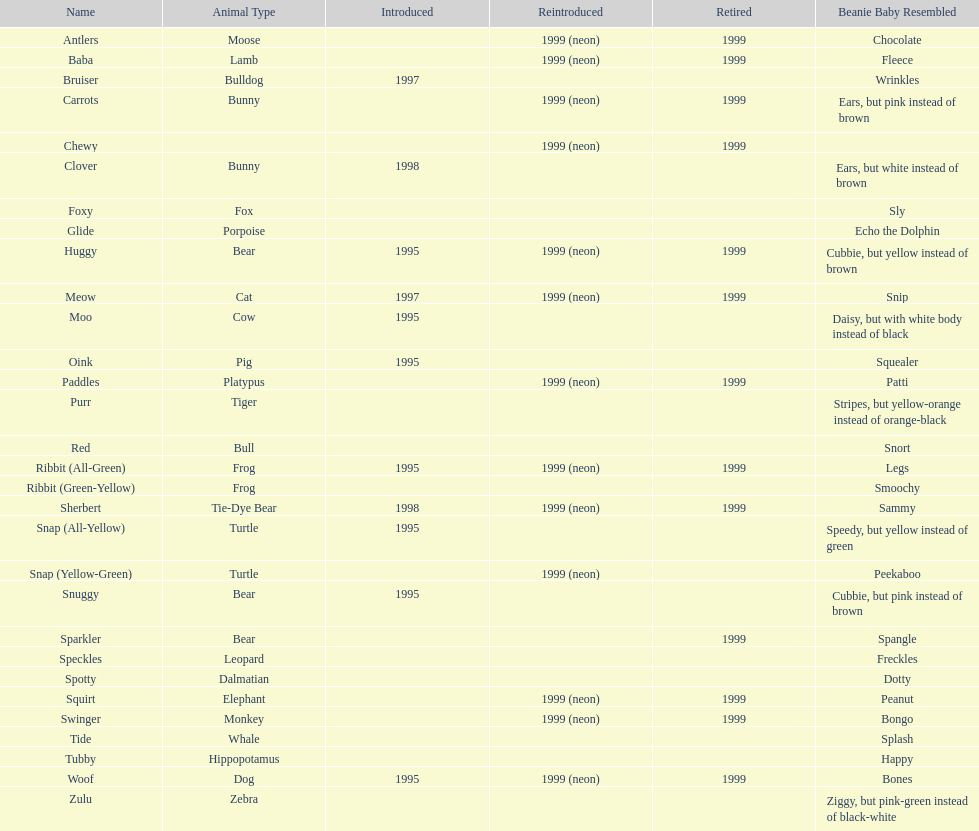What was the total number of monkey pillow pals? 1. 